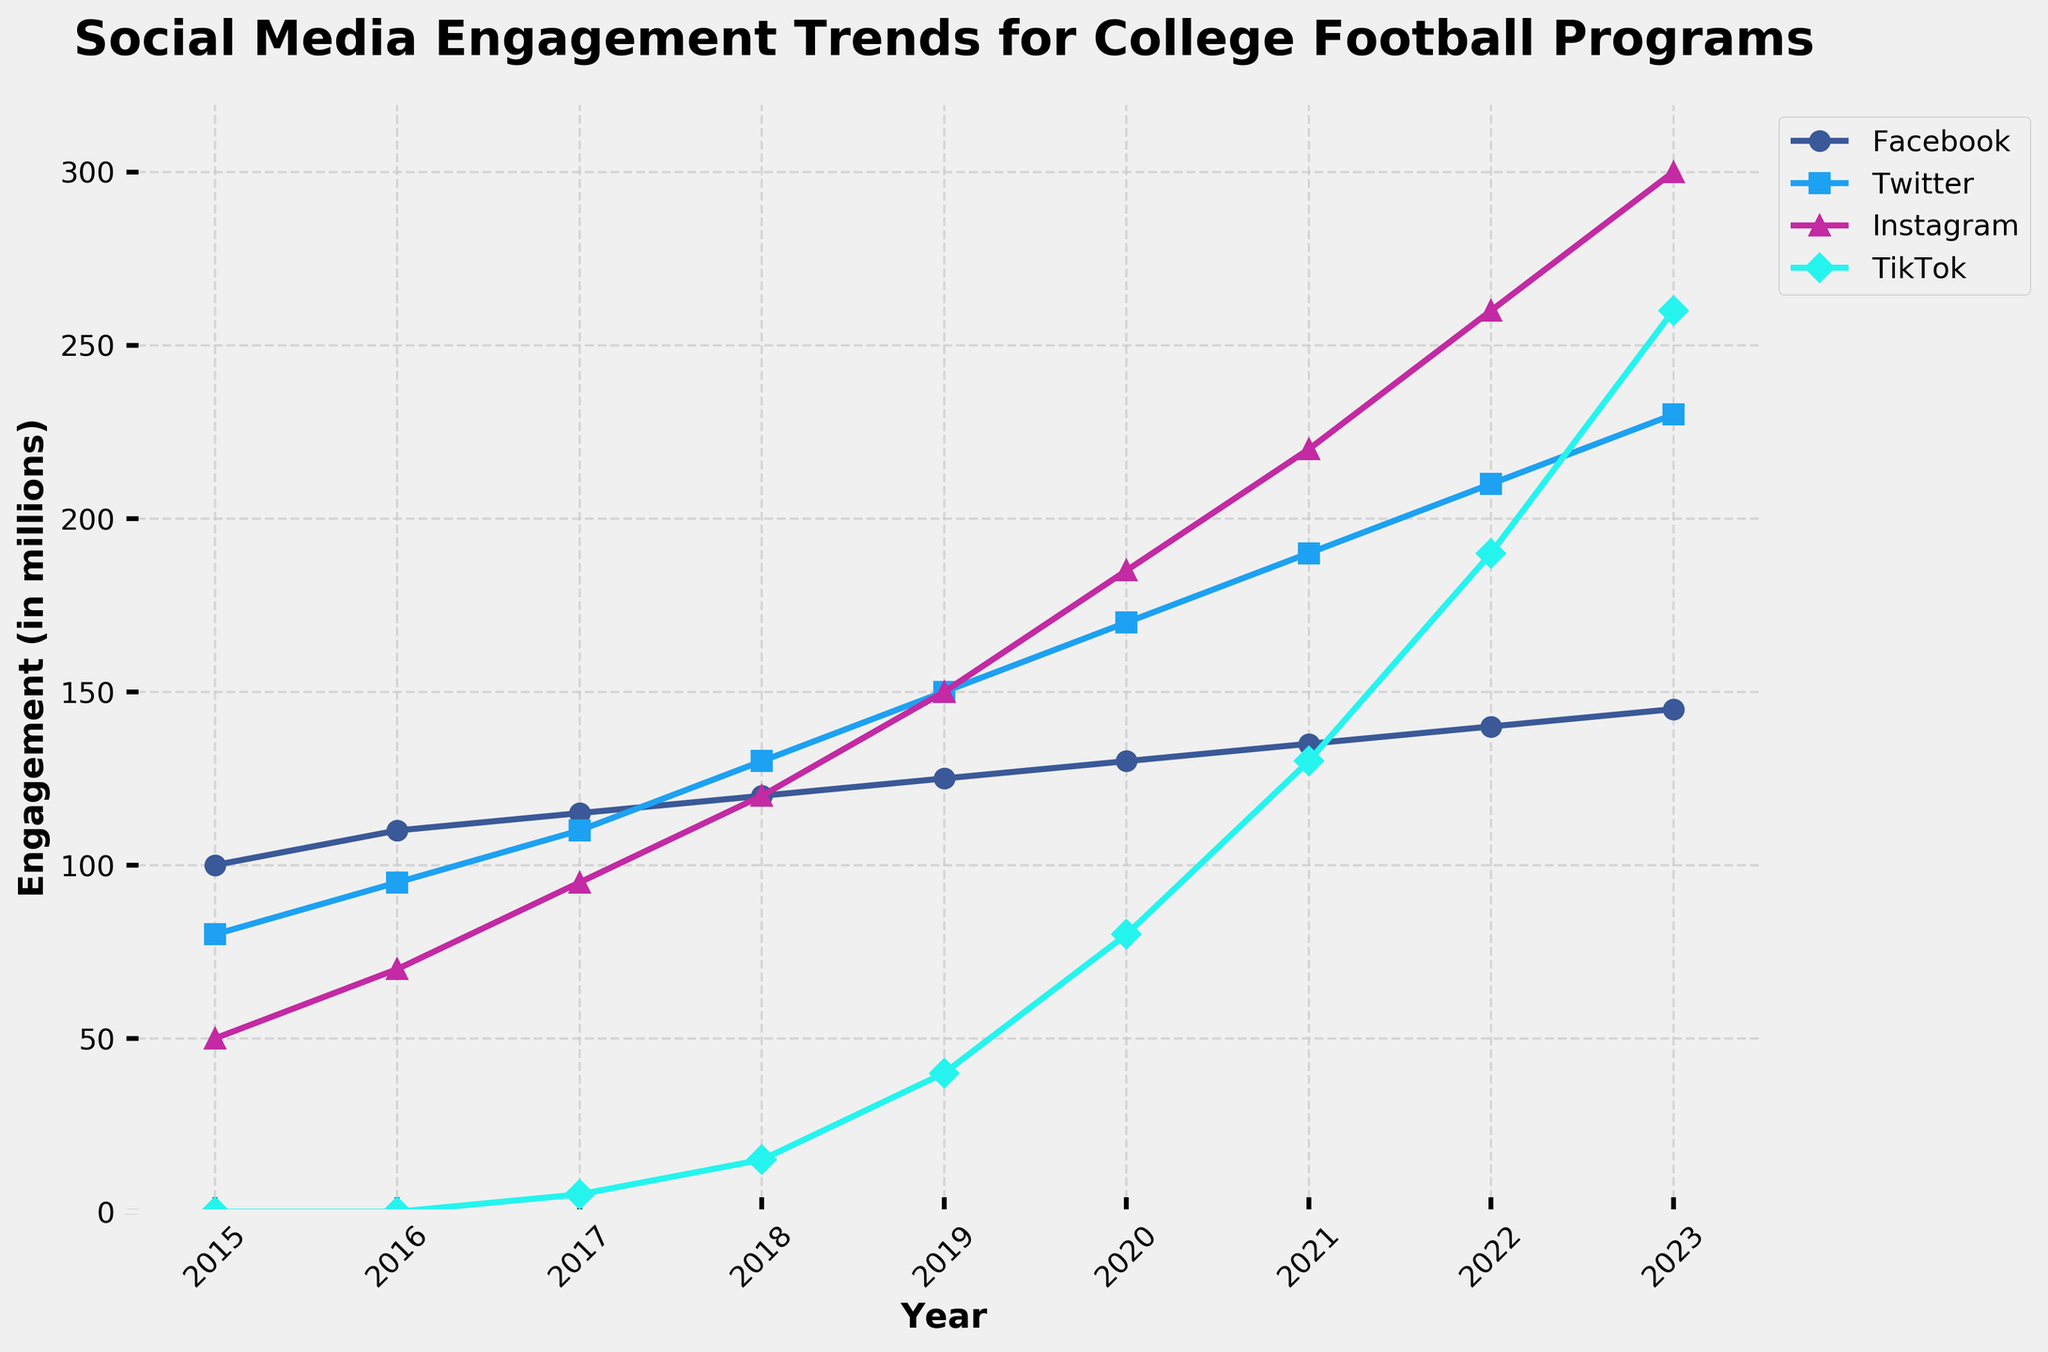What is the trend of engagement on TikTok from 2015 to 2023? The trend shows that TikTok engagement started from 0 in 2015, gradually increasing each year, reaching 260 in 2023. Each year sees a noticeable rise in engagement, which indicates a growing popularity of TikTok over time.
Answer: Increasing Which platform had the highest engagement in 2023? In 2023, Instagram had the highest engagement. By observing the end points of each line in the graph, we can see that the Instagram line ends at 300, which is higher than the endpoints of the other platforms.
Answer: Instagram By how much did Twitter engagement increase from 2015 to 2023? Twitter engagement can be seen increasing from 80 in 2015 to 230 in 2023. The increase is calculated by subtracting the engagement in 2015 from that in 2023: 230 - 80 = 150.
Answer: 150 In which year did Instagram's engagement surpass Facebook's engagement? Instagram's engagement surpasses Facebook's engagement in 2018. By looking at the graph, we can see that the Instagram line crosses above the Facebook line between 2017 and 2018.
Answer: 2018 What was the total engagement across all platforms in 2020? Facebook: 130, Twitter: 170, Instagram: 185, TikTok: 80. Adding these together gives: 130 + 170 + 185 + 80 = 565.
Answer: 565 Which year observed the highest increase in TikTok engagement? The highest increase in TikTok engagement is from 2020 to 2021. From the graph, TikTok's engagement jumped from 80 in 2020 to 130 in 2021, which is an increase of 50.
Answer: 2021 How does the engagement on Instagram in 2022 compare with the engagement on Twitter in 2018? Instagram's engagement in 2022 is 260, while Twitter's engagement in 2018 is 130. Comparing these values, Instagram's engagement in 2022 is twice as much as Twitter's engagement in 2018.
Answer: More than double What is the average engagement for Facebook over the years presented in the graph? Facebook engagement figures are: 100, 110, 115, 120, 125, 130, 135, 140, and 145. The sum of these values is 1115. To find the average, divide by the number of years (9): 1115 / 9 ≈ 123.89.
Answer: ~124 In which year was the difference between Instagram and TikTok engagement the largest? The difference is largest in 2023. Instagram: 300, TikTok: 260. Difference: 300 - 260 = 40. Comparing yearly differences, 2023 has the largest difference.
Answer: 2023 What can be inferred about the overall trend for social media engagement for college football programs from 2015 to 2023? The overall trend for all platforms shows a steady increase in engagement from 2015 to 2023. Facebook, Twitter, and Instagram show consistent growth, but TikTok, which starts later in 2017, shows a steeper increase in the few years it is represented, indicating rapid adoption and growing popularity.
Answer: Increasing trend 